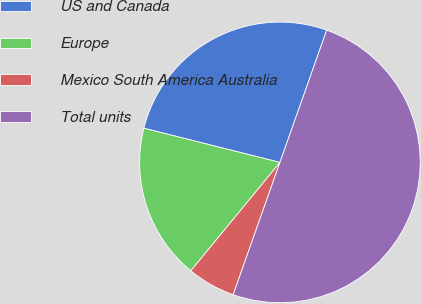Convert chart to OTSL. <chart><loc_0><loc_0><loc_500><loc_500><pie_chart><fcel>US and Canada<fcel>Europe<fcel>Mexico South America Australia<fcel>Total units<nl><fcel>26.49%<fcel>17.97%<fcel>5.54%<fcel>50.0%<nl></chart> 